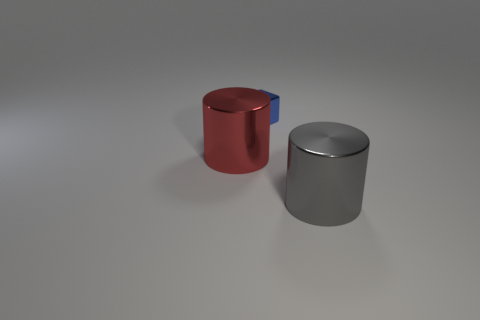Add 1 brown blocks. How many objects exist? 4 Subtract all cubes. How many objects are left? 2 Add 3 big things. How many big things exist? 5 Subtract 0 red cubes. How many objects are left? 3 Subtract all metallic objects. Subtract all cyan shiny cylinders. How many objects are left? 0 Add 3 blue things. How many blue things are left? 4 